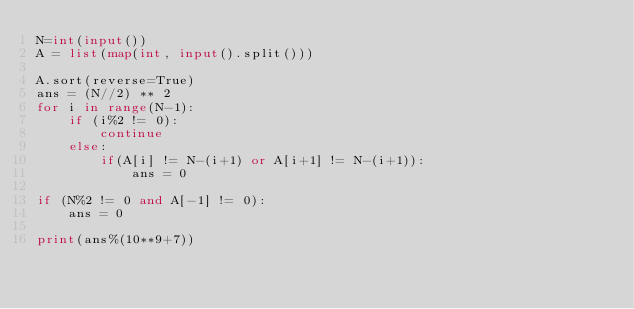Convert code to text. <code><loc_0><loc_0><loc_500><loc_500><_Python_>N=int(input())
A = list(map(int, input().split()))

A.sort(reverse=True)
ans = (N//2) ** 2
for i in range(N-1):
    if (i%2 != 0):
        continue
    else:
        if(A[i] != N-(i+1) or A[i+1] != N-(i+1)):
            ans = 0

if (N%2 != 0 and A[-1] != 0):
    ans = 0

print(ans%(10**9+7))
</code> 